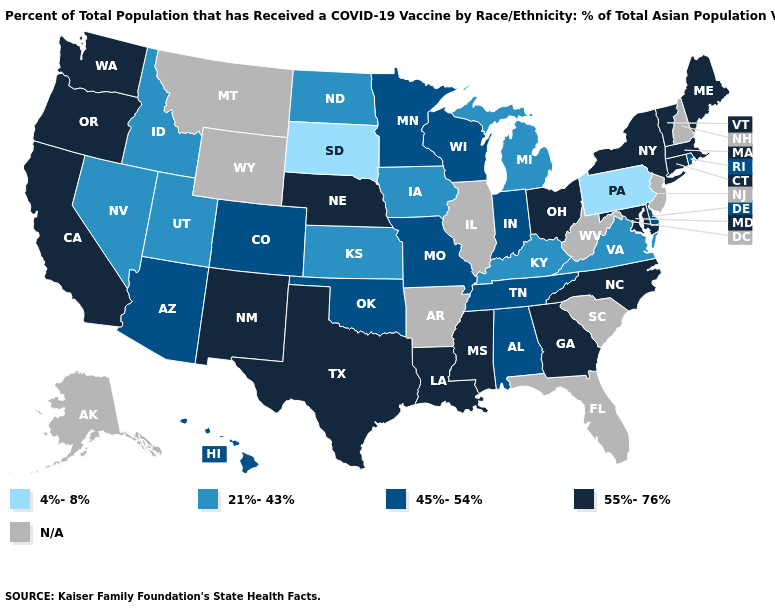Does Idaho have the lowest value in the USA?
Write a very short answer. No. Does the first symbol in the legend represent the smallest category?
Quick response, please. Yes. What is the lowest value in the USA?
Write a very short answer. 4%-8%. Name the states that have a value in the range 55%-76%?
Answer briefly. California, Connecticut, Georgia, Louisiana, Maine, Maryland, Massachusetts, Mississippi, Nebraska, New Mexico, New York, North Carolina, Ohio, Oregon, Texas, Vermont, Washington. What is the value of Utah?
Quick response, please. 21%-43%. Name the states that have a value in the range 21%-43%?
Answer briefly. Idaho, Iowa, Kansas, Kentucky, Michigan, Nevada, North Dakota, Utah, Virginia. Name the states that have a value in the range 55%-76%?
Give a very brief answer. California, Connecticut, Georgia, Louisiana, Maine, Maryland, Massachusetts, Mississippi, Nebraska, New Mexico, New York, North Carolina, Ohio, Oregon, Texas, Vermont, Washington. What is the lowest value in states that border Utah?
Concise answer only. 21%-43%. Which states have the lowest value in the South?
Be succinct. Kentucky, Virginia. Among the states that border Idaho , does Oregon have the highest value?
Short answer required. Yes. What is the value of Idaho?
Be succinct. 21%-43%. What is the value of Montana?
Answer briefly. N/A. Which states hav the highest value in the South?
Concise answer only. Georgia, Louisiana, Maryland, Mississippi, North Carolina, Texas. 